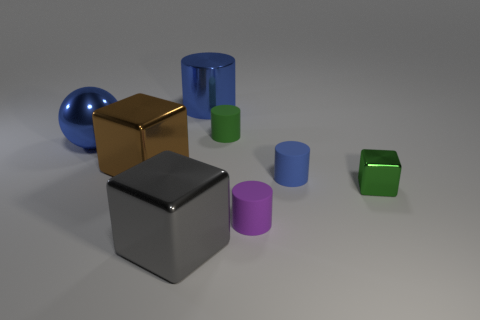Subtract all large gray metallic blocks. How many blocks are left? 2 Subtract all purple blocks. How many blue cylinders are left? 2 Subtract 2 cylinders. How many cylinders are left? 2 Subtract all gray cubes. How many cubes are left? 2 Subtract all red cylinders. Subtract all green spheres. How many cylinders are left? 4 Subtract all cubes. How many objects are left? 5 Add 1 big green shiny objects. How many objects exist? 9 Add 1 blue metallic balls. How many blue metallic balls exist? 2 Subtract 1 blue cylinders. How many objects are left? 7 Subtract all rubber cylinders. Subtract all big objects. How many objects are left? 1 